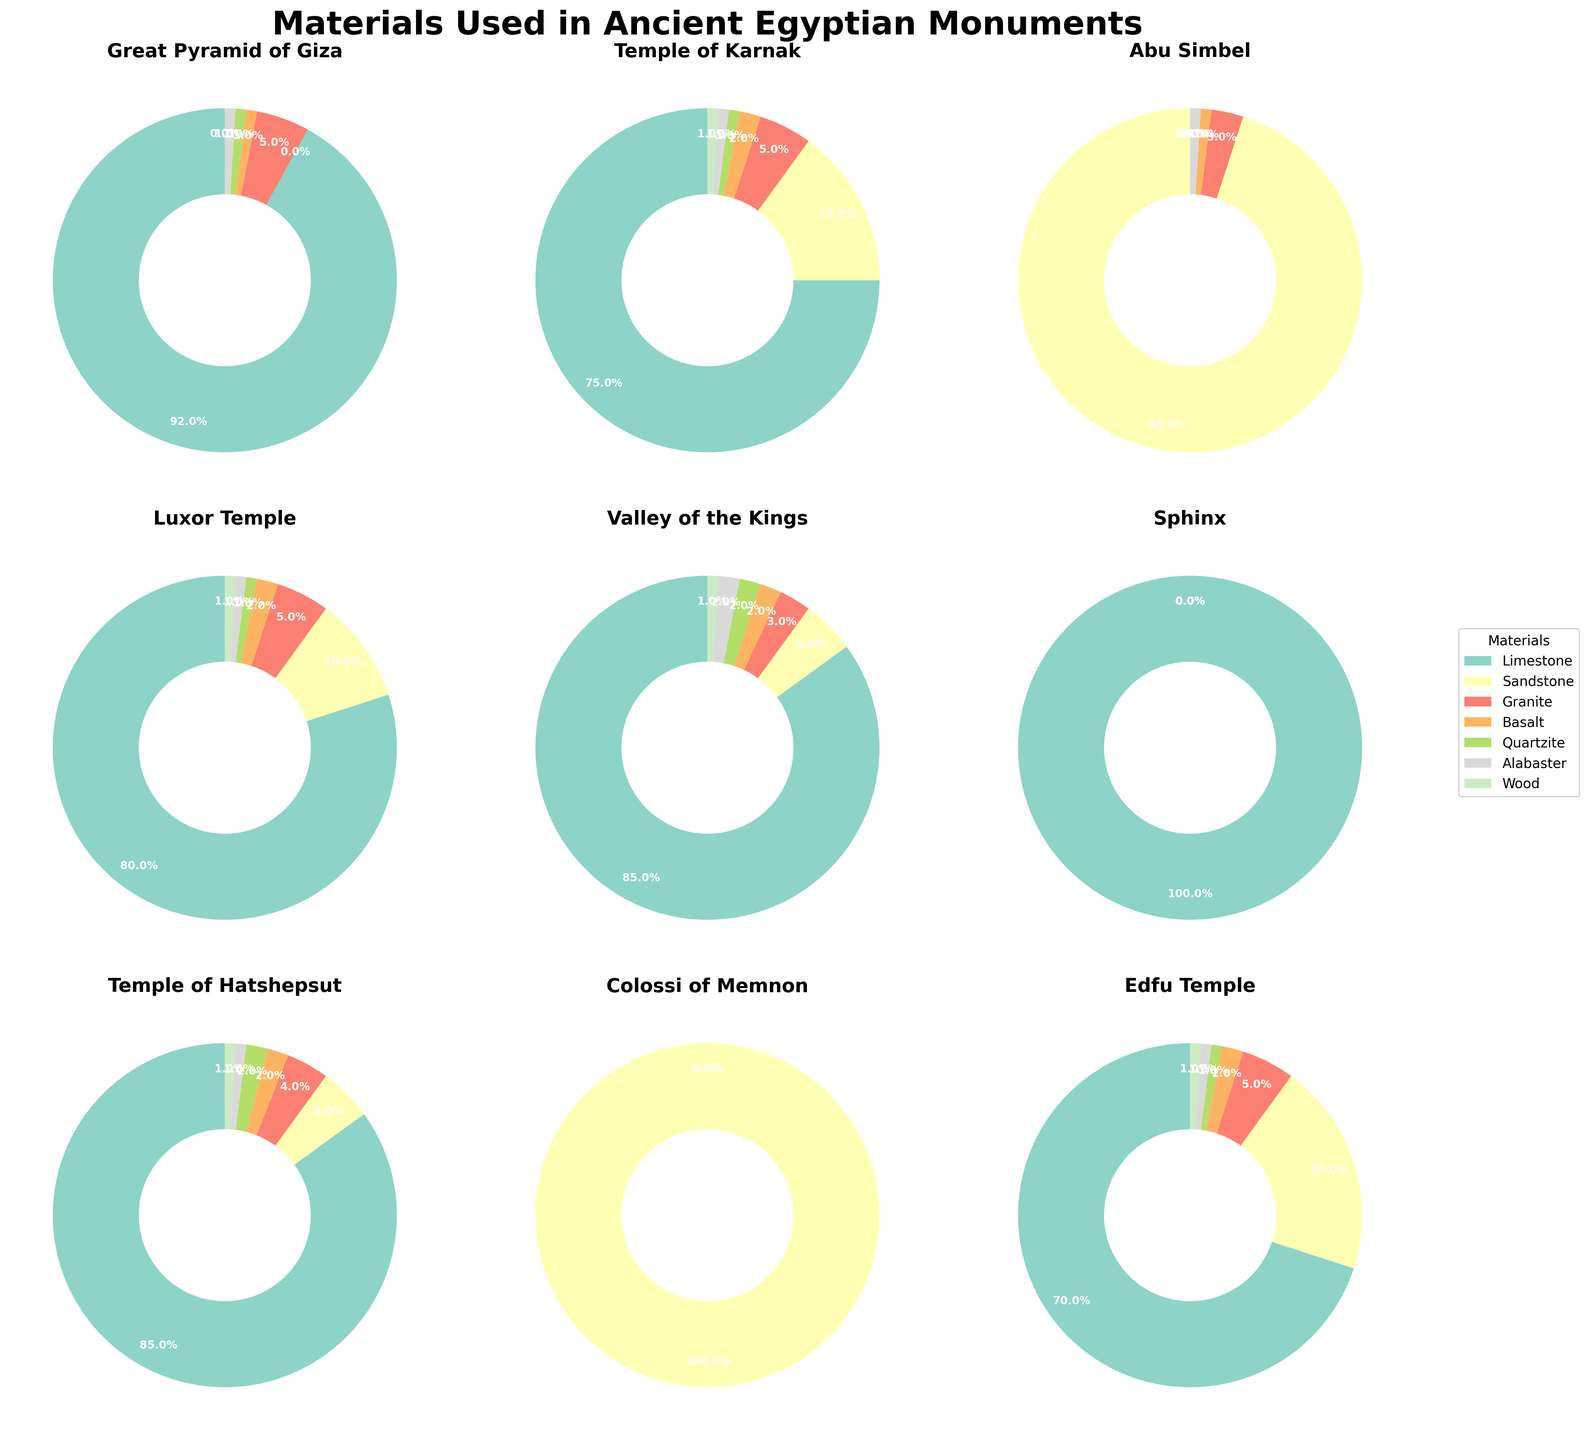Which monument contains the highest percentage of limestone? Look at the segments representing limestone in each pie chart and identify the monument with the largest segment. The Great Pyramid of Giza has the largest segment for limestone, making up 92% of its materials.
Answer: Great Pyramid of Giza Which monument uses sandstone most exclusively? Compare the sizes of the sandstone segments across all monuments. The Colossi of Memnon and Abu Simbel have the largest and nearly exclusive sandstone segments. Both monuments use 100% and 95% sandstone respectively.
Answer: Colossi of Memnon How does the usage of granite in the Temple of Karnak compare to the Great Pyramid of Giza? Check the granite segments in the pie charts for both monuments. The Temple of Karnak and the Great Pyramid of Giza both have granite segments, but the size of the segment is 5% for both monuments. Thus, they use granite equally.
Answer: Equal What is the combined percentage of basalt and quartzite in the Luxor Temple? Find the segments representing basalt and quartzite in the Luxor Temple pie chart. Basalt is 2% and quartzite is 1%. Add these two percentages: 2% + 1% = 3%.
Answer: 3% Which monument does not use wood at all? Check for the presence of the wood segment in each pie chart. The Sphinx does not have a segment for wood, indicating it uses 0% wood.
Answer: Sphinx Which monument has the most diverse range of materials used? Look at the number of different materials used in each pie chart. The Temple of Karnak, Luxor Temple, Valley of the Kings, Temple of Hatshepsut, Edfu Temple, and Philae Temple all use six different materials. So, it's any one of these; they all have the most diverse range of materials.
Answer: Temple of Karnak (or any of the six-material monuments) What is the difference in alabaster usage between the Valley of the Kings and Abu Simbel? Check the alabaster segments in both monuments' pie charts. Valley of the Kings uses 2% alabaster, while Abu Simbel uses 1%. The difference is 2% - 1% = 1%.
Answer: 1% Is the percentage of sandstone usage in the Colossi of Memnon equal to the percentage of limestone usage in the Sphinx? Compare the segments for sandstone in the Colossi of Memnon and limestone in the Sphinx. Both charts show 100% usage.
Answer: Yes Which monument has a higher proportion of usage of quartzite, Temple of Hatshepsut or Valley of the Kings? Check the quartzite segments in the pie charts. Temple of Hatshepsut uses 2% quartzite, while Valley of the Kings also uses 2%. Thus, they have the same proportion of usage.
Answer: Equal 